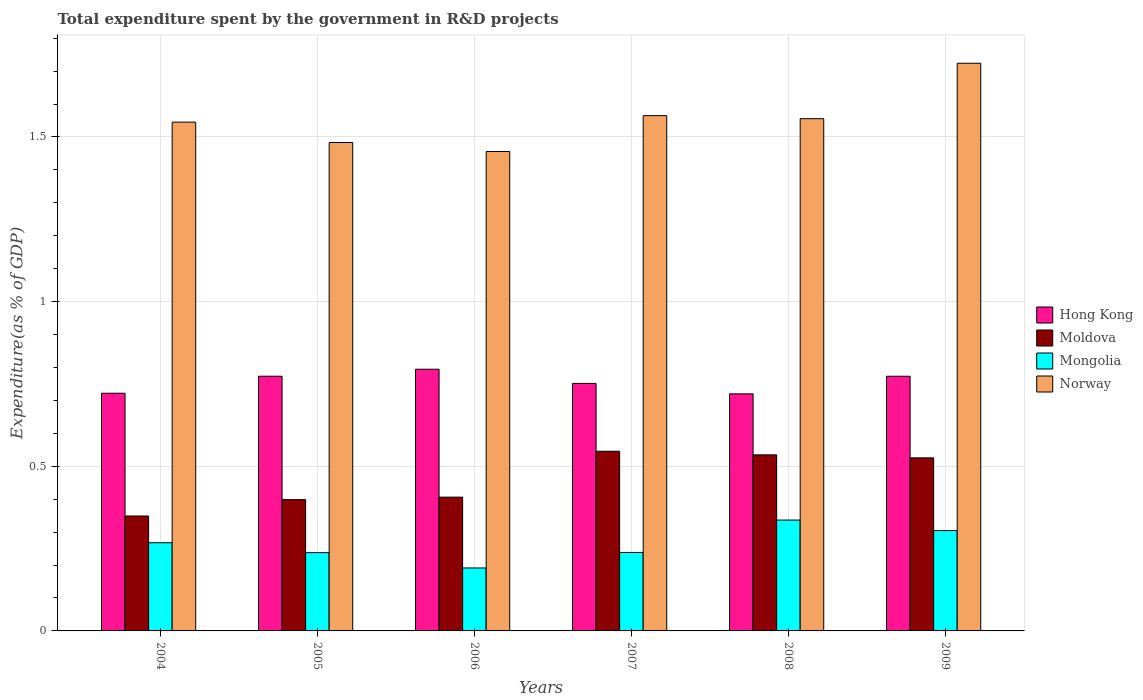How many different coloured bars are there?
Offer a very short reply. 4. How many groups of bars are there?
Give a very brief answer. 6. Are the number of bars per tick equal to the number of legend labels?
Provide a succinct answer. Yes. Are the number of bars on each tick of the X-axis equal?
Your response must be concise. Yes. How many bars are there on the 3rd tick from the right?
Give a very brief answer. 4. In how many cases, is the number of bars for a given year not equal to the number of legend labels?
Your response must be concise. 0. What is the total expenditure spent by the government in R&D projects in Norway in 2008?
Make the answer very short. 1.56. Across all years, what is the maximum total expenditure spent by the government in R&D projects in Hong Kong?
Give a very brief answer. 0.79. Across all years, what is the minimum total expenditure spent by the government in R&D projects in Hong Kong?
Keep it short and to the point. 0.72. In which year was the total expenditure spent by the government in R&D projects in Mongolia maximum?
Offer a very short reply. 2008. What is the total total expenditure spent by the government in R&D projects in Mongolia in the graph?
Provide a short and direct response. 1.58. What is the difference between the total expenditure spent by the government in R&D projects in Norway in 2004 and that in 2008?
Ensure brevity in your answer.  -0.01. What is the difference between the total expenditure spent by the government in R&D projects in Mongolia in 2005 and the total expenditure spent by the government in R&D projects in Moldova in 2009?
Make the answer very short. -0.29. What is the average total expenditure spent by the government in R&D projects in Moldova per year?
Offer a very short reply. 0.46. In the year 2008, what is the difference between the total expenditure spent by the government in R&D projects in Mongolia and total expenditure spent by the government in R&D projects in Hong Kong?
Offer a very short reply. -0.38. What is the ratio of the total expenditure spent by the government in R&D projects in Moldova in 2006 to that in 2007?
Provide a short and direct response. 0.74. What is the difference between the highest and the second highest total expenditure spent by the government in R&D projects in Mongolia?
Give a very brief answer. 0.03. What is the difference between the highest and the lowest total expenditure spent by the government in R&D projects in Hong Kong?
Keep it short and to the point. 0.07. In how many years, is the total expenditure spent by the government in R&D projects in Norway greater than the average total expenditure spent by the government in R&D projects in Norway taken over all years?
Give a very brief answer. 3. Is the sum of the total expenditure spent by the government in R&D projects in Mongolia in 2004 and 2008 greater than the maximum total expenditure spent by the government in R&D projects in Moldova across all years?
Provide a succinct answer. Yes. Is it the case that in every year, the sum of the total expenditure spent by the government in R&D projects in Norway and total expenditure spent by the government in R&D projects in Mongolia is greater than the sum of total expenditure spent by the government in R&D projects in Hong Kong and total expenditure spent by the government in R&D projects in Moldova?
Give a very brief answer. Yes. What does the 3rd bar from the left in 2006 represents?
Offer a terse response. Mongolia. What does the 3rd bar from the right in 2005 represents?
Provide a short and direct response. Moldova. Is it the case that in every year, the sum of the total expenditure spent by the government in R&D projects in Hong Kong and total expenditure spent by the government in R&D projects in Mongolia is greater than the total expenditure spent by the government in R&D projects in Norway?
Ensure brevity in your answer.  No. Are all the bars in the graph horizontal?
Your response must be concise. No. What is the difference between two consecutive major ticks on the Y-axis?
Provide a succinct answer. 0.5. Where does the legend appear in the graph?
Keep it short and to the point. Center right. How many legend labels are there?
Offer a terse response. 4. What is the title of the graph?
Give a very brief answer. Total expenditure spent by the government in R&D projects. Does "Bangladesh" appear as one of the legend labels in the graph?
Provide a succinct answer. No. What is the label or title of the X-axis?
Offer a very short reply. Years. What is the label or title of the Y-axis?
Your response must be concise. Expenditure(as % of GDP). What is the Expenditure(as % of GDP) of Hong Kong in 2004?
Offer a terse response. 0.72. What is the Expenditure(as % of GDP) in Moldova in 2004?
Your answer should be very brief. 0.35. What is the Expenditure(as % of GDP) of Mongolia in 2004?
Your answer should be very brief. 0.27. What is the Expenditure(as % of GDP) of Norway in 2004?
Your response must be concise. 1.55. What is the Expenditure(as % of GDP) in Hong Kong in 2005?
Your answer should be very brief. 0.77. What is the Expenditure(as % of GDP) of Moldova in 2005?
Offer a terse response. 0.4. What is the Expenditure(as % of GDP) of Mongolia in 2005?
Offer a terse response. 0.24. What is the Expenditure(as % of GDP) of Norway in 2005?
Provide a short and direct response. 1.48. What is the Expenditure(as % of GDP) of Hong Kong in 2006?
Keep it short and to the point. 0.79. What is the Expenditure(as % of GDP) of Moldova in 2006?
Offer a terse response. 0.41. What is the Expenditure(as % of GDP) of Mongolia in 2006?
Keep it short and to the point. 0.19. What is the Expenditure(as % of GDP) in Norway in 2006?
Give a very brief answer. 1.46. What is the Expenditure(as % of GDP) of Hong Kong in 2007?
Keep it short and to the point. 0.75. What is the Expenditure(as % of GDP) in Moldova in 2007?
Provide a short and direct response. 0.55. What is the Expenditure(as % of GDP) of Mongolia in 2007?
Provide a short and direct response. 0.24. What is the Expenditure(as % of GDP) of Norway in 2007?
Make the answer very short. 1.56. What is the Expenditure(as % of GDP) of Hong Kong in 2008?
Your answer should be compact. 0.72. What is the Expenditure(as % of GDP) in Moldova in 2008?
Keep it short and to the point. 0.53. What is the Expenditure(as % of GDP) in Mongolia in 2008?
Your answer should be compact. 0.34. What is the Expenditure(as % of GDP) of Norway in 2008?
Offer a very short reply. 1.56. What is the Expenditure(as % of GDP) of Hong Kong in 2009?
Give a very brief answer. 0.77. What is the Expenditure(as % of GDP) of Moldova in 2009?
Provide a succinct answer. 0.53. What is the Expenditure(as % of GDP) of Mongolia in 2009?
Provide a succinct answer. 0.3. What is the Expenditure(as % of GDP) in Norway in 2009?
Provide a succinct answer. 1.72. Across all years, what is the maximum Expenditure(as % of GDP) in Hong Kong?
Give a very brief answer. 0.79. Across all years, what is the maximum Expenditure(as % of GDP) of Moldova?
Offer a terse response. 0.55. Across all years, what is the maximum Expenditure(as % of GDP) in Mongolia?
Make the answer very short. 0.34. Across all years, what is the maximum Expenditure(as % of GDP) in Norway?
Offer a very short reply. 1.72. Across all years, what is the minimum Expenditure(as % of GDP) in Hong Kong?
Offer a very short reply. 0.72. Across all years, what is the minimum Expenditure(as % of GDP) of Moldova?
Make the answer very short. 0.35. Across all years, what is the minimum Expenditure(as % of GDP) in Mongolia?
Offer a very short reply. 0.19. Across all years, what is the minimum Expenditure(as % of GDP) in Norway?
Make the answer very short. 1.46. What is the total Expenditure(as % of GDP) in Hong Kong in the graph?
Provide a succinct answer. 4.53. What is the total Expenditure(as % of GDP) in Moldova in the graph?
Ensure brevity in your answer.  2.76. What is the total Expenditure(as % of GDP) of Mongolia in the graph?
Ensure brevity in your answer.  1.58. What is the total Expenditure(as % of GDP) of Norway in the graph?
Keep it short and to the point. 9.33. What is the difference between the Expenditure(as % of GDP) of Hong Kong in 2004 and that in 2005?
Make the answer very short. -0.05. What is the difference between the Expenditure(as % of GDP) of Moldova in 2004 and that in 2005?
Your response must be concise. -0.05. What is the difference between the Expenditure(as % of GDP) of Norway in 2004 and that in 2005?
Keep it short and to the point. 0.06. What is the difference between the Expenditure(as % of GDP) in Hong Kong in 2004 and that in 2006?
Your answer should be compact. -0.07. What is the difference between the Expenditure(as % of GDP) in Moldova in 2004 and that in 2006?
Make the answer very short. -0.06. What is the difference between the Expenditure(as % of GDP) of Mongolia in 2004 and that in 2006?
Give a very brief answer. 0.08. What is the difference between the Expenditure(as % of GDP) in Norway in 2004 and that in 2006?
Offer a very short reply. 0.09. What is the difference between the Expenditure(as % of GDP) in Hong Kong in 2004 and that in 2007?
Make the answer very short. -0.03. What is the difference between the Expenditure(as % of GDP) in Moldova in 2004 and that in 2007?
Make the answer very short. -0.2. What is the difference between the Expenditure(as % of GDP) of Mongolia in 2004 and that in 2007?
Offer a very short reply. 0.03. What is the difference between the Expenditure(as % of GDP) in Norway in 2004 and that in 2007?
Give a very brief answer. -0.02. What is the difference between the Expenditure(as % of GDP) of Hong Kong in 2004 and that in 2008?
Offer a terse response. 0. What is the difference between the Expenditure(as % of GDP) in Moldova in 2004 and that in 2008?
Your response must be concise. -0.19. What is the difference between the Expenditure(as % of GDP) of Mongolia in 2004 and that in 2008?
Your response must be concise. -0.07. What is the difference between the Expenditure(as % of GDP) of Norway in 2004 and that in 2008?
Your answer should be compact. -0.01. What is the difference between the Expenditure(as % of GDP) in Hong Kong in 2004 and that in 2009?
Provide a short and direct response. -0.05. What is the difference between the Expenditure(as % of GDP) in Moldova in 2004 and that in 2009?
Make the answer very short. -0.18. What is the difference between the Expenditure(as % of GDP) in Mongolia in 2004 and that in 2009?
Ensure brevity in your answer.  -0.04. What is the difference between the Expenditure(as % of GDP) of Norway in 2004 and that in 2009?
Provide a succinct answer. -0.18. What is the difference between the Expenditure(as % of GDP) in Hong Kong in 2005 and that in 2006?
Provide a succinct answer. -0.02. What is the difference between the Expenditure(as % of GDP) of Moldova in 2005 and that in 2006?
Your response must be concise. -0.01. What is the difference between the Expenditure(as % of GDP) in Mongolia in 2005 and that in 2006?
Provide a succinct answer. 0.05. What is the difference between the Expenditure(as % of GDP) in Norway in 2005 and that in 2006?
Offer a terse response. 0.03. What is the difference between the Expenditure(as % of GDP) of Hong Kong in 2005 and that in 2007?
Give a very brief answer. 0.02. What is the difference between the Expenditure(as % of GDP) of Moldova in 2005 and that in 2007?
Ensure brevity in your answer.  -0.15. What is the difference between the Expenditure(as % of GDP) of Mongolia in 2005 and that in 2007?
Offer a terse response. -0. What is the difference between the Expenditure(as % of GDP) of Norway in 2005 and that in 2007?
Provide a short and direct response. -0.08. What is the difference between the Expenditure(as % of GDP) of Hong Kong in 2005 and that in 2008?
Ensure brevity in your answer.  0.05. What is the difference between the Expenditure(as % of GDP) of Moldova in 2005 and that in 2008?
Provide a succinct answer. -0.14. What is the difference between the Expenditure(as % of GDP) of Mongolia in 2005 and that in 2008?
Offer a very short reply. -0.1. What is the difference between the Expenditure(as % of GDP) in Norway in 2005 and that in 2008?
Provide a short and direct response. -0.07. What is the difference between the Expenditure(as % of GDP) in Hong Kong in 2005 and that in 2009?
Ensure brevity in your answer.  0. What is the difference between the Expenditure(as % of GDP) of Moldova in 2005 and that in 2009?
Make the answer very short. -0.13. What is the difference between the Expenditure(as % of GDP) of Mongolia in 2005 and that in 2009?
Ensure brevity in your answer.  -0.07. What is the difference between the Expenditure(as % of GDP) of Norway in 2005 and that in 2009?
Offer a terse response. -0.24. What is the difference between the Expenditure(as % of GDP) in Hong Kong in 2006 and that in 2007?
Provide a short and direct response. 0.04. What is the difference between the Expenditure(as % of GDP) of Moldova in 2006 and that in 2007?
Provide a short and direct response. -0.14. What is the difference between the Expenditure(as % of GDP) of Mongolia in 2006 and that in 2007?
Provide a succinct answer. -0.05. What is the difference between the Expenditure(as % of GDP) in Norway in 2006 and that in 2007?
Your response must be concise. -0.11. What is the difference between the Expenditure(as % of GDP) in Hong Kong in 2006 and that in 2008?
Provide a short and direct response. 0.07. What is the difference between the Expenditure(as % of GDP) of Moldova in 2006 and that in 2008?
Ensure brevity in your answer.  -0.13. What is the difference between the Expenditure(as % of GDP) in Mongolia in 2006 and that in 2008?
Provide a short and direct response. -0.15. What is the difference between the Expenditure(as % of GDP) of Norway in 2006 and that in 2008?
Keep it short and to the point. -0.1. What is the difference between the Expenditure(as % of GDP) of Hong Kong in 2006 and that in 2009?
Provide a succinct answer. 0.02. What is the difference between the Expenditure(as % of GDP) in Moldova in 2006 and that in 2009?
Provide a succinct answer. -0.12. What is the difference between the Expenditure(as % of GDP) of Mongolia in 2006 and that in 2009?
Provide a succinct answer. -0.11. What is the difference between the Expenditure(as % of GDP) of Norway in 2006 and that in 2009?
Offer a very short reply. -0.27. What is the difference between the Expenditure(as % of GDP) in Hong Kong in 2007 and that in 2008?
Offer a very short reply. 0.03. What is the difference between the Expenditure(as % of GDP) in Moldova in 2007 and that in 2008?
Provide a succinct answer. 0.01. What is the difference between the Expenditure(as % of GDP) of Mongolia in 2007 and that in 2008?
Make the answer very short. -0.1. What is the difference between the Expenditure(as % of GDP) in Norway in 2007 and that in 2008?
Provide a succinct answer. 0.01. What is the difference between the Expenditure(as % of GDP) of Hong Kong in 2007 and that in 2009?
Keep it short and to the point. -0.02. What is the difference between the Expenditure(as % of GDP) of Mongolia in 2007 and that in 2009?
Ensure brevity in your answer.  -0.07. What is the difference between the Expenditure(as % of GDP) of Norway in 2007 and that in 2009?
Provide a succinct answer. -0.16. What is the difference between the Expenditure(as % of GDP) in Hong Kong in 2008 and that in 2009?
Make the answer very short. -0.05. What is the difference between the Expenditure(as % of GDP) of Moldova in 2008 and that in 2009?
Your response must be concise. 0.01. What is the difference between the Expenditure(as % of GDP) in Mongolia in 2008 and that in 2009?
Your response must be concise. 0.03. What is the difference between the Expenditure(as % of GDP) in Norway in 2008 and that in 2009?
Keep it short and to the point. -0.17. What is the difference between the Expenditure(as % of GDP) in Hong Kong in 2004 and the Expenditure(as % of GDP) in Moldova in 2005?
Your answer should be very brief. 0.32. What is the difference between the Expenditure(as % of GDP) in Hong Kong in 2004 and the Expenditure(as % of GDP) in Mongolia in 2005?
Offer a terse response. 0.48. What is the difference between the Expenditure(as % of GDP) in Hong Kong in 2004 and the Expenditure(as % of GDP) in Norway in 2005?
Ensure brevity in your answer.  -0.76. What is the difference between the Expenditure(as % of GDP) in Moldova in 2004 and the Expenditure(as % of GDP) in Mongolia in 2005?
Give a very brief answer. 0.11. What is the difference between the Expenditure(as % of GDP) of Moldova in 2004 and the Expenditure(as % of GDP) of Norway in 2005?
Keep it short and to the point. -1.13. What is the difference between the Expenditure(as % of GDP) of Mongolia in 2004 and the Expenditure(as % of GDP) of Norway in 2005?
Offer a terse response. -1.22. What is the difference between the Expenditure(as % of GDP) in Hong Kong in 2004 and the Expenditure(as % of GDP) in Moldova in 2006?
Your answer should be compact. 0.32. What is the difference between the Expenditure(as % of GDP) of Hong Kong in 2004 and the Expenditure(as % of GDP) of Mongolia in 2006?
Your answer should be very brief. 0.53. What is the difference between the Expenditure(as % of GDP) of Hong Kong in 2004 and the Expenditure(as % of GDP) of Norway in 2006?
Your answer should be very brief. -0.73. What is the difference between the Expenditure(as % of GDP) in Moldova in 2004 and the Expenditure(as % of GDP) in Mongolia in 2006?
Offer a terse response. 0.16. What is the difference between the Expenditure(as % of GDP) in Moldova in 2004 and the Expenditure(as % of GDP) in Norway in 2006?
Keep it short and to the point. -1.11. What is the difference between the Expenditure(as % of GDP) of Mongolia in 2004 and the Expenditure(as % of GDP) of Norway in 2006?
Keep it short and to the point. -1.19. What is the difference between the Expenditure(as % of GDP) of Hong Kong in 2004 and the Expenditure(as % of GDP) of Moldova in 2007?
Provide a short and direct response. 0.18. What is the difference between the Expenditure(as % of GDP) in Hong Kong in 2004 and the Expenditure(as % of GDP) in Mongolia in 2007?
Your answer should be compact. 0.48. What is the difference between the Expenditure(as % of GDP) of Hong Kong in 2004 and the Expenditure(as % of GDP) of Norway in 2007?
Make the answer very short. -0.84. What is the difference between the Expenditure(as % of GDP) of Moldova in 2004 and the Expenditure(as % of GDP) of Mongolia in 2007?
Your answer should be compact. 0.11. What is the difference between the Expenditure(as % of GDP) of Moldova in 2004 and the Expenditure(as % of GDP) of Norway in 2007?
Make the answer very short. -1.22. What is the difference between the Expenditure(as % of GDP) of Mongolia in 2004 and the Expenditure(as % of GDP) of Norway in 2007?
Provide a short and direct response. -1.3. What is the difference between the Expenditure(as % of GDP) in Hong Kong in 2004 and the Expenditure(as % of GDP) in Moldova in 2008?
Keep it short and to the point. 0.19. What is the difference between the Expenditure(as % of GDP) in Hong Kong in 2004 and the Expenditure(as % of GDP) in Mongolia in 2008?
Offer a terse response. 0.39. What is the difference between the Expenditure(as % of GDP) of Hong Kong in 2004 and the Expenditure(as % of GDP) of Norway in 2008?
Provide a succinct answer. -0.83. What is the difference between the Expenditure(as % of GDP) in Moldova in 2004 and the Expenditure(as % of GDP) in Mongolia in 2008?
Provide a short and direct response. 0.01. What is the difference between the Expenditure(as % of GDP) of Moldova in 2004 and the Expenditure(as % of GDP) of Norway in 2008?
Your answer should be very brief. -1.21. What is the difference between the Expenditure(as % of GDP) of Mongolia in 2004 and the Expenditure(as % of GDP) of Norway in 2008?
Your answer should be compact. -1.29. What is the difference between the Expenditure(as % of GDP) in Hong Kong in 2004 and the Expenditure(as % of GDP) in Moldova in 2009?
Give a very brief answer. 0.2. What is the difference between the Expenditure(as % of GDP) of Hong Kong in 2004 and the Expenditure(as % of GDP) of Mongolia in 2009?
Your answer should be compact. 0.42. What is the difference between the Expenditure(as % of GDP) in Hong Kong in 2004 and the Expenditure(as % of GDP) in Norway in 2009?
Your response must be concise. -1. What is the difference between the Expenditure(as % of GDP) of Moldova in 2004 and the Expenditure(as % of GDP) of Mongolia in 2009?
Ensure brevity in your answer.  0.04. What is the difference between the Expenditure(as % of GDP) in Moldova in 2004 and the Expenditure(as % of GDP) in Norway in 2009?
Your answer should be very brief. -1.37. What is the difference between the Expenditure(as % of GDP) of Mongolia in 2004 and the Expenditure(as % of GDP) of Norway in 2009?
Keep it short and to the point. -1.46. What is the difference between the Expenditure(as % of GDP) of Hong Kong in 2005 and the Expenditure(as % of GDP) of Moldova in 2006?
Ensure brevity in your answer.  0.37. What is the difference between the Expenditure(as % of GDP) in Hong Kong in 2005 and the Expenditure(as % of GDP) in Mongolia in 2006?
Keep it short and to the point. 0.58. What is the difference between the Expenditure(as % of GDP) of Hong Kong in 2005 and the Expenditure(as % of GDP) of Norway in 2006?
Your response must be concise. -0.68. What is the difference between the Expenditure(as % of GDP) in Moldova in 2005 and the Expenditure(as % of GDP) in Mongolia in 2006?
Offer a terse response. 0.21. What is the difference between the Expenditure(as % of GDP) in Moldova in 2005 and the Expenditure(as % of GDP) in Norway in 2006?
Keep it short and to the point. -1.06. What is the difference between the Expenditure(as % of GDP) of Mongolia in 2005 and the Expenditure(as % of GDP) of Norway in 2006?
Provide a short and direct response. -1.22. What is the difference between the Expenditure(as % of GDP) of Hong Kong in 2005 and the Expenditure(as % of GDP) of Moldova in 2007?
Offer a terse response. 0.23. What is the difference between the Expenditure(as % of GDP) of Hong Kong in 2005 and the Expenditure(as % of GDP) of Mongolia in 2007?
Keep it short and to the point. 0.54. What is the difference between the Expenditure(as % of GDP) in Hong Kong in 2005 and the Expenditure(as % of GDP) in Norway in 2007?
Provide a short and direct response. -0.79. What is the difference between the Expenditure(as % of GDP) in Moldova in 2005 and the Expenditure(as % of GDP) in Mongolia in 2007?
Your response must be concise. 0.16. What is the difference between the Expenditure(as % of GDP) in Moldova in 2005 and the Expenditure(as % of GDP) in Norway in 2007?
Your answer should be compact. -1.17. What is the difference between the Expenditure(as % of GDP) in Mongolia in 2005 and the Expenditure(as % of GDP) in Norway in 2007?
Your answer should be compact. -1.33. What is the difference between the Expenditure(as % of GDP) in Hong Kong in 2005 and the Expenditure(as % of GDP) in Moldova in 2008?
Ensure brevity in your answer.  0.24. What is the difference between the Expenditure(as % of GDP) of Hong Kong in 2005 and the Expenditure(as % of GDP) of Mongolia in 2008?
Offer a terse response. 0.44. What is the difference between the Expenditure(as % of GDP) in Hong Kong in 2005 and the Expenditure(as % of GDP) in Norway in 2008?
Your response must be concise. -0.78. What is the difference between the Expenditure(as % of GDP) in Moldova in 2005 and the Expenditure(as % of GDP) in Mongolia in 2008?
Ensure brevity in your answer.  0.06. What is the difference between the Expenditure(as % of GDP) in Moldova in 2005 and the Expenditure(as % of GDP) in Norway in 2008?
Make the answer very short. -1.16. What is the difference between the Expenditure(as % of GDP) in Mongolia in 2005 and the Expenditure(as % of GDP) in Norway in 2008?
Ensure brevity in your answer.  -1.32. What is the difference between the Expenditure(as % of GDP) in Hong Kong in 2005 and the Expenditure(as % of GDP) in Moldova in 2009?
Provide a short and direct response. 0.25. What is the difference between the Expenditure(as % of GDP) in Hong Kong in 2005 and the Expenditure(as % of GDP) in Mongolia in 2009?
Your answer should be compact. 0.47. What is the difference between the Expenditure(as % of GDP) in Hong Kong in 2005 and the Expenditure(as % of GDP) in Norway in 2009?
Your answer should be very brief. -0.95. What is the difference between the Expenditure(as % of GDP) of Moldova in 2005 and the Expenditure(as % of GDP) of Mongolia in 2009?
Your answer should be very brief. 0.09. What is the difference between the Expenditure(as % of GDP) in Moldova in 2005 and the Expenditure(as % of GDP) in Norway in 2009?
Offer a terse response. -1.33. What is the difference between the Expenditure(as % of GDP) of Mongolia in 2005 and the Expenditure(as % of GDP) of Norway in 2009?
Make the answer very short. -1.49. What is the difference between the Expenditure(as % of GDP) in Hong Kong in 2006 and the Expenditure(as % of GDP) in Moldova in 2007?
Your answer should be very brief. 0.25. What is the difference between the Expenditure(as % of GDP) in Hong Kong in 2006 and the Expenditure(as % of GDP) in Mongolia in 2007?
Your response must be concise. 0.56. What is the difference between the Expenditure(as % of GDP) of Hong Kong in 2006 and the Expenditure(as % of GDP) of Norway in 2007?
Your answer should be compact. -0.77. What is the difference between the Expenditure(as % of GDP) in Moldova in 2006 and the Expenditure(as % of GDP) in Mongolia in 2007?
Your response must be concise. 0.17. What is the difference between the Expenditure(as % of GDP) of Moldova in 2006 and the Expenditure(as % of GDP) of Norway in 2007?
Provide a short and direct response. -1.16. What is the difference between the Expenditure(as % of GDP) of Mongolia in 2006 and the Expenditure(as % of GDP) of Norway in 2007?
Your answer should be very brief. -1.37. What is the difference between the Expenditure(as % of GDP) in Hong Kong in 2006 and the Expenditure(as % of GDP) in Moldova in 2008?
Provide a succinct answer. 0.26. What is the difference between the Expenditure(as % of GDP) in Hong Kong in 2006 and the Expenditure(as % of GDP) in Mongolia in 2008?
Provide a short and direct response. 0.46. What is the difference between the Expenditure(as % of GDP) in Hong Kong in 2006 and the Expenditure(as % of GDP) in Norway in 2008?
Give a very brief answer. -0.76. What is the difference between the Expenditure(as % of GDP) of Moldova in 2006 and the Expenditure(as % of GDP) of Mongolia in 2008?
Your answer should be very brief. 0.07. What is the difference between the Expenditure(as % of GDP) of Moldova in 2006 and the Expenditure(as % of GDP) of Norway in 2008?
Provide a succinct answer. -1.15. What is the difference between the Expenditure(as % of GDP) of Mongolia in 2006 and the Expenditure(as % of GDP) of Norway in 2008?
Provide a succinct answer. -1.36. What is the difference between the Expenditure(as % of GDP) in Hong Kong in 2006 and the Expenditure(as % of GDP) in Moldova in 2009?
Keep it short and to the point. 0.27. What is the difference between the Expenditure(as % of GDP) of Hong Kong in 2006 and the Expenditure(as % of GDP) of Mongolia in 2009?
Your answer should be very brief. 0.49. What is the difference between the Expenditure(as % of GDP) of Hong Kong in 2006 and the Expenditure(as % of GDP) of Norway in 2009?
Ensure brevity in your answer.  -0.93. What is the difference between the Expenditure(as % of GDP) in Moldova in 2006 and the Expenditure(as % of GDP) in Mongolia in 2009?
Offer a terse response. 0.1. What is the difference between the Expenditure(as % of GDP) of Moldova in 2006 and the Expenditure(as % of GDP) of Norway in 2009?
Give a very brief answer. -1.32. What is the difference between the Expenditure(as % of GDP) in Mongolia in 2006 and the Expenditure(as % of GDP) in Norway in 2009?
Your response must be concise. -1.53. What is the difference between the Expenditure(as % of GDP) of Hong Kong in 2007 and the Expenditure(as % of GDP) of Moldova in 2008?
Your answer should be very brief. 0.22. What is the difference between the Expenditure(as % of GDP) in Hong Kong in 2007 and the Expenditure(as % of GDP) in Mongolia in 2008?
Your answer should be compact. 0.41. What is the difference between the Expenditure(as % of GDP) in Hong Kong in 2007 and the Expenditure(as % of GDP) in Norway in 2008?
Make the answer very short. -0.8. What is the difference between the Expenditure(as % of GDP) in Moldova in 2007 and the Expenditure(as % of GDP) in Mongolia in 2008?
Your answer should be very brief. 0.21. What is the difference between the Expenditure(as % of GDP) of Moldova in 2007 and the Expenditure(as % of GDP) of Norway in 2008?
Offer a very short reply. -1.01. What is the difference between the Expenditure(as % of GDP) in Mongolia in 2007 and the Expenditure(as % of GDP) in Norway in 2008?
Offer a terse response. -1.32. What is the difference between the Expenditure(as % of GDP) in Hong Kong in 2007 and the Expenditure(as % of GDP) in Moldova in 2009?
Provide a succinct answer. 0.23. What is the difference between the Expenditure(as % of GDP) of Hong Kong in 2007 and the Expenditure(as % of GDP) of Mongolia in 2009?
Keep it short and to the point. 0.45. What is the difference between the Expenditure(as % of GDP) in Hong Kong in 2007 and the Expenditure(as % of GDP) in Norway in 2009?
Make the answer very short. -0.97. What is the difference between the Expenditure(as % of GDP) in Moldova in 2007 and the Expenditure(as % of GDP) in Mongolia in 2009?
Make the answer very short. 0.24. What is the difference between the Expenditure(as % of GDP) of Moldova in 2007 and the Expenditure(as % of GDP) of Norway in 2009?
Your answer should be very brief. -1.18. What is the difference between the Expenditure(as % of GDP) in Mongolia in 2007 and the Expenditure(as % of GDP) in Norway in 2009?
Give a very brief answer. -1.49. What is the difference between the Expenditure(as % of GDP) of Hong Kong in 2008 and the Expenditure(as % of GDP) of Moldova in 2009?
Keep it short and to the point. 0.19. What is the difference between the Expenditure(as % of GDP) of Hong Kong in 2008 and the Expenditure(as % of GDP) of Mongolia in 2009?
Make the answer very short. 0.42. What is the difference between the Expenditure(as % of GDP) of Hong Kong in 2008 and the Expenditure(as % of GDP) of Norway in 2009?
Make the answer very short. -1. What is the difference between the Expenditure(as % of GDP) of Moldova in 2008 and the Expenditure(as % of GDP) of Mongolia in 2009?
Your answer should be compact. 0.23. What is the difference between the Expenditure(as % of GDP) of Moldova in 2008 and the Expenditure(as % of GDP) of Norway in 2009?
Your answer should be compact. -1.19. What is the difference between the Expenditure(as % of GDP) in Mongolia in 2008 and the Expenditure(as % of GDP) in Norway in 2009?
Offer a terse response. -1.39. What is the average Expenditure(as % of GDP) in Hong Kong per year?
Your answer should be compact. 0.76. What is the average Expenditure(as % of GDP) in Moldova per year?
Keep it short and to the point. 0.46. What is the average Expenditure(as % of GDP) of Mongolia per year?
Your answer should be very brief. 0.26. What is the average Expenditure(as % of GDP) in Norway per year?
Provide a short and direct response. 1.55. In the year 2004, what is the difference between the Expenditure(as % of GDP) of Hong Kong and Expenditure(as % of GDP) of Moldova?
Provide a short and direct response. 0.37. In the year 2004, what is the difference between the Expenditure(as % of GDP) in Hong Kong and Expenditure(as % of GDP) in Mongolia?
Give a very brief answer. 0.45. In the year 2004, what is the difference between the Expenditure(as % of GDP) in Hong Kong and Expenditure(as % of GDP) in Norway?
Make the answer very short. -0.82. In the year 2004, what is the difference between the Expenditure(as % of GDP) in Moldova and Expenditure(as % of GDP) in Mongolia?
Offer a terse response. 0.08. In the year 2004, what is the difference between the Expenditure(as % of GDP) in Moldova and Expenditure(as % of GDP) in Norway?
Provide a short and direct response. -1.2. In the year 2004, what is the difference between the Expenditure(as % of GDP) of Mongolia and Expenditure(as % of GDP) of Norway?
Offer a very short reply. -1.28. In the year 2005, what is the difference between the Expenditure(as % of GDP) in Hong Kong and Expenditure(as % of GDP) in Moldova?
Ensure brevity in your answer.  0.37. In the year 2005, what is the difference between the Expenditure(as % of GDP) in Hong Kong and Expenditure(as % of GDP) in Mongolia?
Your response must be concise. 0.54. In the year 2005, what is the difference between the Expenditure(as % of GDP) of Hong Kong and Expenditure(as % of GDP) of Norway?
Provide a succinct answer. -0.71. In the year 2005, what is the difference between the Expenditure(as % of GDP) in Moldova and Expenditure(as % of GDP) in Mongolia?
Offer a very short reply. 0.16. In the year 2005, what is the difference between the Expenditure(as % of GDP) of Moldova and Expenditure(as % of GDP) of Norway?
Provide a short and direct response. -1.08. In the year 2005, what is the difference between the Expenditure(as % of GDP) of Mongolia and Expenditure(as % of GDP) of Norway?
Provide a succinct answer. -1.25. In the year 2006, what is the difference between the Expenditure(as % of GDP) in Hong Kong and Expenditure(as % of GDP) in Moldova?
Your answer should be compact. 0.39. In the year 2006, what is the difference between the Expenditure(as % of GDP) of Hong Kong and Expenditure(as % of GDP) of Mongolia?
Your answer should be very brief. 0.6. In the year 2006, what is the difference between the Expenditure(as % of GDP) of Hong Kong and Expenditure(as % of GDP) of Norway?
Provide a succinct answer. -0.66. In the year 2006, what is the difference between the Expenditure(as % of GDP) of Moldova and Expenditure(as % of GDP) of Mongolia?
Offer a terse response. 0.21. In the year 2006, what is the difference between the Expenditure(as % of GDP) in Moldova and Expenditure(as % of GDP) in Norway?
Your answer should be very brief. -1.05. In the year 2006, what is the difference between the Expenditure(as % of GDP) in Mongolia and Expenditure(as % of GDP) in Norway?
Your response must be concise. -1.26. In the year 2007, what is the difference between the Expenditure(as % of GDP) in Hong Kong and Expenditure(as % of GDP) in Moldova?
Provide a short and direct response. 0.21. In the year 2007, what is the difference between the Expenditure(as % of GDP) in Hong Kong and Expenditure(as % of GDP) in Mongolia?
Your answer should be very brief. 0.51. In the year 2007, what is the difference between the Expenditure(as % of GDP) in Hong Kong and Expenditure(as % of GDP) in Norway?
Keep it short and to the point. -0.81. In the year 2007, what is the difference between the Expenditure(as % of GDP) of Moldova and Expenditure(as % of GDP) of Mongolia?
Your response must be concise. 0.31. In the year 2007, what is the difference between the Expenditure(as % of GDP) of Moldova and Expenditure(as % of GDP) of Norway?
Your answer should be very brief. -1.02. In the year 2007, what is the difference between the Expenditure(as % of GDP) in Mongolia and Expenditure(as % of GDP) in Norway?
Give a very brief answer. -1.33. In the year 2008, what is the difference between the Expenditure(as % of GDP) in Hong Kong and Expenditure(as % of GDP) in Moldova?
Ensure brevity in your answer.  0.19. In the year 2008, what is the difference between the Expenditure(as % of GDP) in Hong Kong and Expenditure(as % of GDP) in Mongolia?
Provide a short and direct response. 0.38. In the year 2008, what is the difference between the Expenditure(as % of GDP) in Hong Kong and Expenditure(as % of GDP) in Norway?
Offer a terse response. -0.84. In the year 2008, what is the difference between the Expenditure(as % of GDP) in Moldova and Expenditure(as % of GDP) in Mongolia?
Keep it short and to the point. 0.2. In the year 2008, what is the difference between the Expenditure(as % of GDP) of Moldova and Expenditure(as % of GDP) of Norway?
Your answer should be compact. -1.02. In the year 2008, what is the difference between the Expenditure(as % of GDP) in Mongolia and Expenditure(as % of GDP) in Norway?
Make the answer very short. -1.22. In the year 2009, what is the difference between the Expenditure(as % of GDP) of Hong Kong and Expenditure(as % of GDP) of Moldova?
Ensure brevity in your answer.  0.25. In the year 2009, what is the difference between the Expenditure(as % of GDP) of Hong Kong and Expenditure(as % of GDP) of Mongolia?
Ensure brevity in your answer.  0.47. In the year 2009, what is the difference between the Expenditure(as % of GDP) in Hong Kong and Expenditure(as % of GDP) in Norway?
Your answer should be compact. -0.95. In the year 2009, what is the difference between the Expenditure(as % of GDP) of Moldova and Expenditure(as % of GDP) of Mongolia?
Your response must be concise. 0.22. In the year 2009, what is the difference between the Expenditure(as % of GDP) of Moldova and Expenditure(as % of GDP) of Norway?
Your answer should be very brief. -1.2. In the year 2009, what is the difference between the Expenditure(as % of GDP) in Mongolia and Expenditure(as % of GDP) in Norway?
Ensure brevity in your answer.  -1.42. What is the ratio of the Expenditure(as % of GDP) in Hong Kong in 2004 to that in 2005?
Your response must be concise. 0.93. What is the ratio of the Expenditure(as % of GDP) in Moldova in 2004 to that in 2005?
Ensure brevity in your answer.  0.88. What is the ratio of the Expenditure(as % of GDP) of Mongolia in 2004 to that in 2005?
Provide a succinct answer. 1.13. What is the ratio of the Expenditure(as % of GDP) in Norway in 2004 to that in 2005?
Your answer should be very brief. 1.04. What is the ratio of the Expenditure(as % of GDP) of Hong Kong in 2004 to that in 2006?
Your response must be concise. 0.91. What is the ratio of the Expenditure(as % of GDP) of Moldova in 2004 to that in 2006?
Make the answer very short. 0.86. What is the ratio of the Expenditure(as % of GDP) in Mongolia in 2004 to that in 2006?
Keep it short and to the point. 1.4. What is the ratio of the Expenditure(as % of GDP) of Norway in 2004 to that in 2006?
Keep it short and to the point. 1.06. What is the ratio of the Expenditure(as % of GDP) of Hong Kong in 2004 to that in 2007?
Make the answer very short. 0.96. What is the ratio of the Expenditure(as % of GDP) of Moldova in 2004 to that in 2007?
Offer a very short reply. 0.64. What is the ratio of the Expenditure(as % of GDP) of Mongolia in 2004 to that in 2007?
Give a very brief answer. 1.12. What is the ratio of the Expenditure(as % of GDP) in Norway in 2004 to that in 2007?
Provide a short and direct response. 0.99. What is the ratio of the Expenditure(as % of GDP) in Hong Kong in 2004 to that in 2008?
Offer a terse response. 1. What is the ratio of the Expenditure(as % of GDP) in Moldova in 2004 to that in 2008?
Ensure brevity in your answer.  0.65. What is the ratio of the Expenditure(as % of GDP) in Mongolia in 2004 to that in 2008?
Offer a very short reply. 0.8. What is the ratio of the Expenditure(as % of GDP) of Hong Kong in 2004 to that in 2009?
Ensure brevity in your answer.  0.93. What is the ratio of the Expenditure(as % of GDP) in Moldova in 2004 to that in 2009?
Offer a very short reply. 0.66. What is the ratio of the Expenditure(as % of GDP) of Mongolia in 2004 to that in 2009?
Give a very brief answer. 0.88. What is the ratio of the Expenditure(as % of GDP) of Norway in 2004 to that in 2009?
Make the answer very short. 0.9. What is the ratio of the Expenditure(as % of GDP) in Hong Kong in 2005 to that in 2006?
Your response must be concise. 0.97. What is the ratio of the Expenditure(as % of GDP) in Moldova in 2005 to that in 2006?
Provide a succinct answer. 0.98. What is the ratio of the Expenditure(as % of GDP) of Mongolia in 2005 to that in 2006?
Your response must be concise. 1.24. What is the ratio of the Expenditure(as % of GDP) in Norway in 2005 to that in 2006?
Provide a short and direct response. 1.02. What is the ratio of the Expenditure(as % of GDP) of Hong Kong in 2005 to that in 2007?
Offer a very short reply. 1.03. What is the ratio of the Expenditure(as % of GDP) in Moldova in 2005 to that in 2007?
Ensure brevity in your answer.  0.73. What is the ratio of the Expenditure(as % of GDP) in Mongolia in 2005 to that in 2007?
Offer a terse response. 1. What is the ratio of the Expenditure(as % of GDP) in Norway in 2005 to that in 2007?
Offer a terse response. 0.95. What is the ratio of the Expenditure(as % of GDP) in Hong Kong in 2005 to that in 2008?
Offer a terse response. 1.07. What is the ratio of the Expenditure(as % of GDP) of Moldova in 2005 to that in 2008?
Your answer should be very brief. 0.75. What is the ratio of the Expenditure(as % of GDP) of Mongolia in 2005 to that in 2008?
Your answer should be compact. 0.71. What is the ratio of the Expenditure(as % of GDP) of Norway in 2005 to that in 2008?
Offer a terse response. 0.95. What is the ratio of the Expenditure(as % of GDP) in Hong Kong in 2005 to that in 2009?
Offer a very short reply. 1. What is the ratio of the Expenditure(as % of GDP) of Moldova in 2005 to that in 2009?
Your response must be concise. 0.76. What is the ratio of the Expenditure(as % of GDP) of Mongolia in 2005 to that in 2009?
Make the answer very short. 0.78. What is the ratio of the Expenditure(as % of GDP) of Norway in 2005 to that in 2009?
Give a very brief answer. 0.86. What is the ratio of the Expenditure(as % of GDP) of Hong Kong in 2006 to that in 2007?
Make the answer very short. 1.06. What is the ratio of the Expenditure(as % of GDP) of Moldova in 2006 to that in 2007?
Give a very brief answer. 0.74. What is the ratio of the Expenditure(as % of GDP) in Mongolia in 2006 to that in 2007?
Provide a short and direct response. 0.8. What is the ratio of the Expenditure(as % of GDP) in Norway in 2006 to that in 2007?
Provide a succinct answer. 0.93. What is the ratio of the Expenditure(as % of GDP) of Hong Kong in 2006 to that in 2008?
Provide a succinct answer. 1.1. What is the ratio of the Expenditure(as % of GDP) in Moldova in 2006 to that in 2008?
Offer a very short reply. 0.76. What is the ratio of the Expenditure(as % of GDP) in Mongolia in 2006 to that in 2008?
Offer a terse response. 0.57. What is the ratio of the Expenditure(as % of GDP) of Norway in 2006 to that in 2008?
Provide a succinct answer. 0.94. What is the ratio of the Expenditure(as % of GDP) in Hong Kong in 2006 to that in 2009?
Provide a short and direct response. 1.03. What is the ratio of the Expenditure(as % of GDP) of Moldova in 2006 to that in 2009?
Offer a very short reply. 0.77. What is the ratio of the Expenditure(as % of GDP) of Mongolia in 2006 to that in 2009?
Give a very brief answer. 0.63. What is the ratio of the Expenditure(as % of GDP) of Norway in 2006 to that in 2009?
Provide a short and direct response. 0.84. What is the ratio of the Expenditure(as % of GDP) in Hong Kong in 2007 to that in 2008?
Make the answer very short. 1.04. What is the ratio of the Expenditure(as % of GDP) in Moldova in 2007 to that in 2008?
Provide a succinct answer. 1.02. What is the ratio of the Expenditure(as % of GDP) of Mongolia in 2007 to that in 2008?
Ensure brevity in your answer.  0.71. What is the ratio of the Expenditure(as % of GDP) of Norway in 2007 to that in 2008?
Your answer should be very brief. 1.01. What is the ratio of the Expenditure(as % of GDP) of Hong Kong in 2007 to that in 2009?
Provide a succinct answer. 0.97. What is the ratio of the Expenditure(as % of GDP) in Moldova in 2007 to that in 2009?
Make the answer very short. 1.04. What is the ratio of the Expenditure(as % of GDP) of Mongolia in 2007 to that in 2009?
Make the answer very short. 0.78. What is the ratio of the Expenditure(as % of GDP) in Norway in 2007 to that in 2009?
Your answer should be very brief. 0.91. What is the ratio of the Expenditure(as % of GDP) of Hong Kong in 2008 to that in 2009?
Provide a short and direct response. 0.93. What is the ratio of the Expenditure(as % of GDP) in Moldova in 2008 to that in 2009?
Your response must be concise. 1.02. What is the ratio of the Expenditure(as % of GDP) of Mongolia in 2008 to that in 2009?
Keep it short and to the point. 1.1. What is the ratio of the Expenditure(as % of GDP) of Norway in 2008 to that in 2009?
Make the answer very short. 0.9. What is the difference between the highest and the second highest Expenditure(as % of GDP) of Hong Kong?
Your answer should be compact. 0.02. What is the difference between the highest and the second highest Expenditure(as % of GDP) of Moldova?
Your answer should be compact. 0.01. What is the difference between the highest and the second highest Expenditure(as % of GDP) in Mongolia?
Your answer should be very brief. 0.03. What is the difference between the highest and the second highest Expenditure(as % of GDP) in Norway?
Provide a short and direct response. 0.16. What is the difference between the highest and the lowest Expenditure(as % of GDP) of Hong Kong?
Provide a short and direct response. 0.07. What is the difference between the highest and the lowest Expenditure(as % of GDP) of Moldova?
Your answer should be compact. 0.2. What is the difference between the highest and the lowest Expenditure(as % of GDP) in Mongolia?
Your answer should be very brief. 0.15. What is the difference between the highest and the lowest Expenditure(as % of GDP) in Norway?
Your answer should be compact. 0.27. 